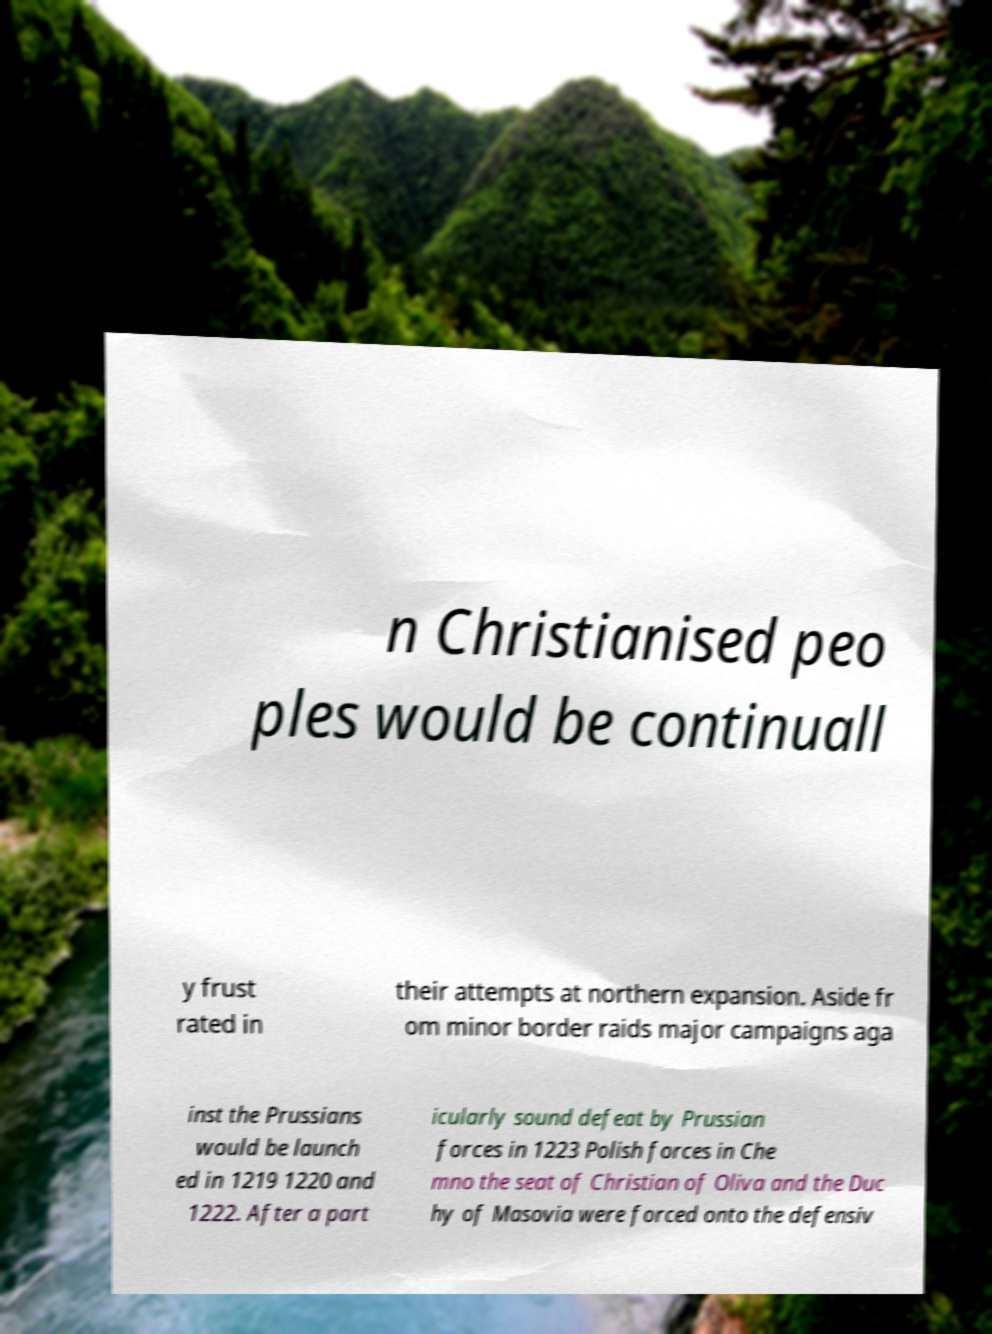Could you assist in decoding the text presented in this image and type it out clearly? n Christianised peo ples would be continuall y frust rated in their attempts at northern expansion. Aside fr om minor border raids major campaigns aga inst the Prussians would be launch ed in 1219 1220 and 1222. After a part icularly sound defeat by Prussian forces in 1223 Polish forces in Che mno the seat of Christian of Oliva and the Duc hy of Masovia were forced onto the defensiv 